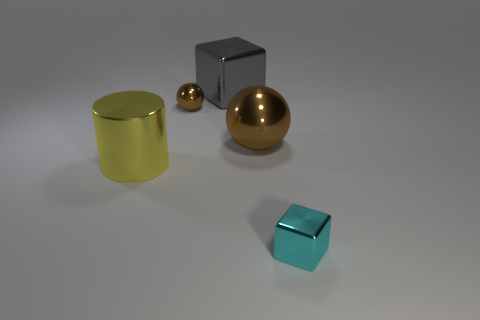Add 3 tiny cyan objects. How many objects exist? 8 Subtract 0 yellow blocks. How many objects are left? 5 Subtract all cylinders. How many objects are left? 4 Subtract all big cyan shiny blocks. Subtract all brown shiny objects. How many objects are left? 3 Add 5 yellow metallic cylinders. How many yellow metallic cylinders are left? 6 Add 1 large gray shiny objects. How many large gray shiny objects exist? 2 